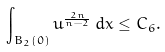Convert formula to latex. <formula><loc_0><loc_0><loc_500><loc_500>\int _ { B _ { 2 } ( 0 ) } u ^ { \frac { 2 n } { n - 2 } } \, d x \leq C _ { 6 } .</formula> 